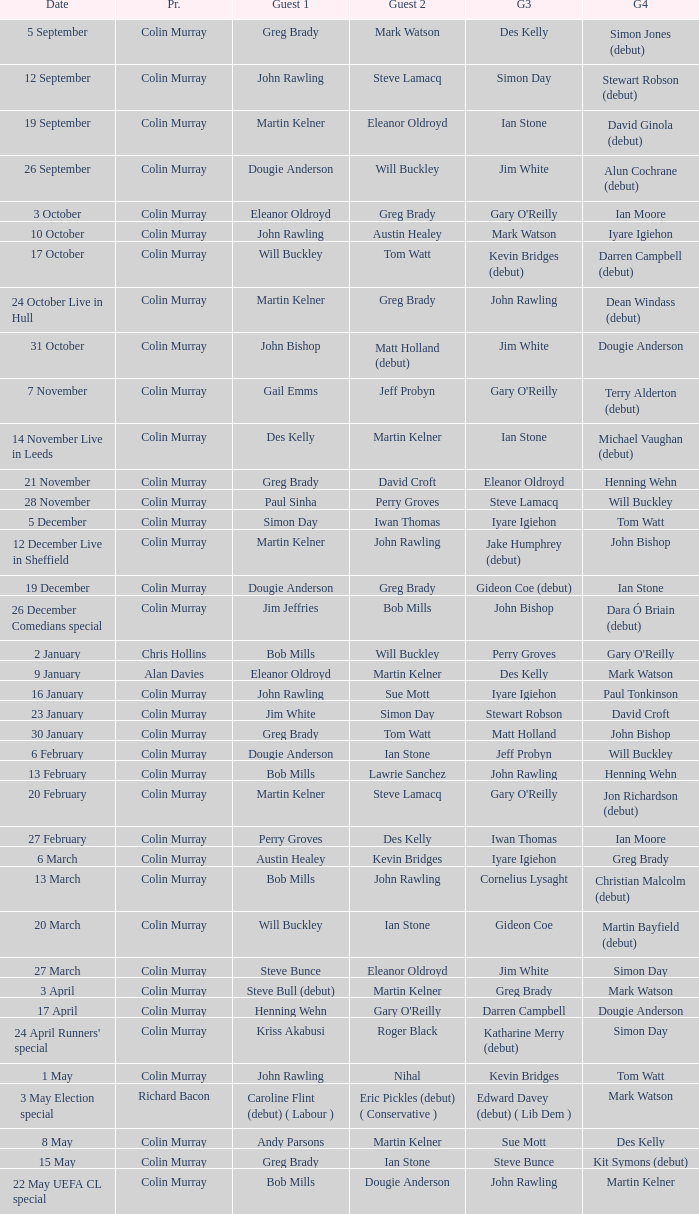On episodes where guest 1 is Jim White, who was guest 3? Stewart Robson. 